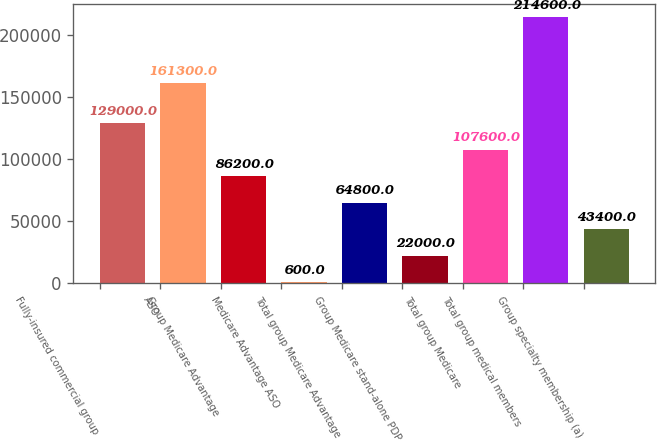Convert chart. <chart><loc_0><loc_0><loc_500><loc_500><bar_chart><fcel>Fully-insured commercial group<fcel>ASO<fcel>Group Medicare Advantage<fcel>Medicare Advantage ASO<fcel>Total group Medicare Advantage<fcel>Group Medicare stand-alone PDP<fcel>Total group Medicare<fcel>Total group medical members<fcel>Group specialty membership (a)<nl><fcel>129000<fcel>161300<fcel>86200<fcel>600<fcel>64800<fcel>22000<fcel>107600<fcel>214600<fcel>43400<nl></chart> 